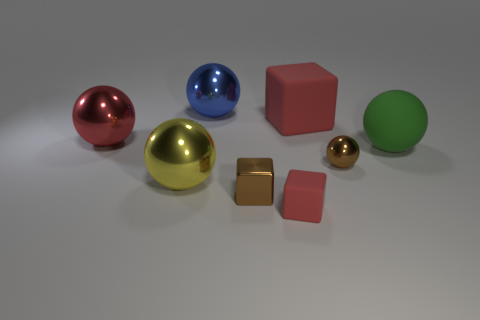Subtract all tiny red rubber cubes. How many cubes are left? 2 Subtract 5 spheres. How many spheres are left? 0 Add 1 tiny red rubber objects. How many objects exist? 9 Subtract all cyan spheres. How many red blocks are left? 2 Subtract all yellow balls. How many balls are left? 4 Subtract all spheres. How many objects are left? 3 Subtract all cyan blocks. Subtract all cyan spheres. How many blocks are left? 3 Subtract all big rubber spheres. Subtract all small things. How many objects are left? 4 Add 6 tiny red cubes. How many tiny red cubes are left? 7 Add 8 tiny balls. How many tiny balls exist? 9 